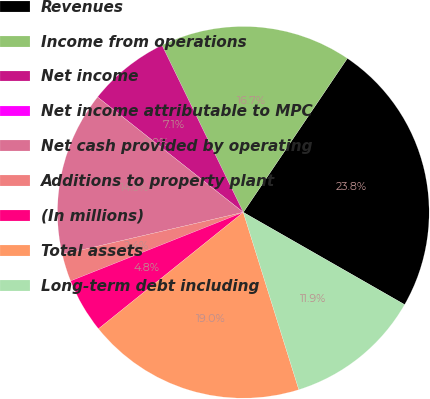Convert chart to OTSL. <chart><loc_0><loc_0><loc_500><loc_500><pie_chart><fcel>Revenues<fcel>Income from operations<fcel>Net income<fcel>Net income attributable to MPC<fcel>Net cash provided by operating<fcel>Additions to property plant<fcel>(In millions)<fcel>Total assets<fcel>Long-term debt including<nl><fcel>23.81%<fcel>16.67%<fcel>7.14%<fcel>0.0%<fcel>14.29%<fcel>2.38%<fcel>4.76%<fcel>19.05%<fcel>11.9%<nl></chart> 